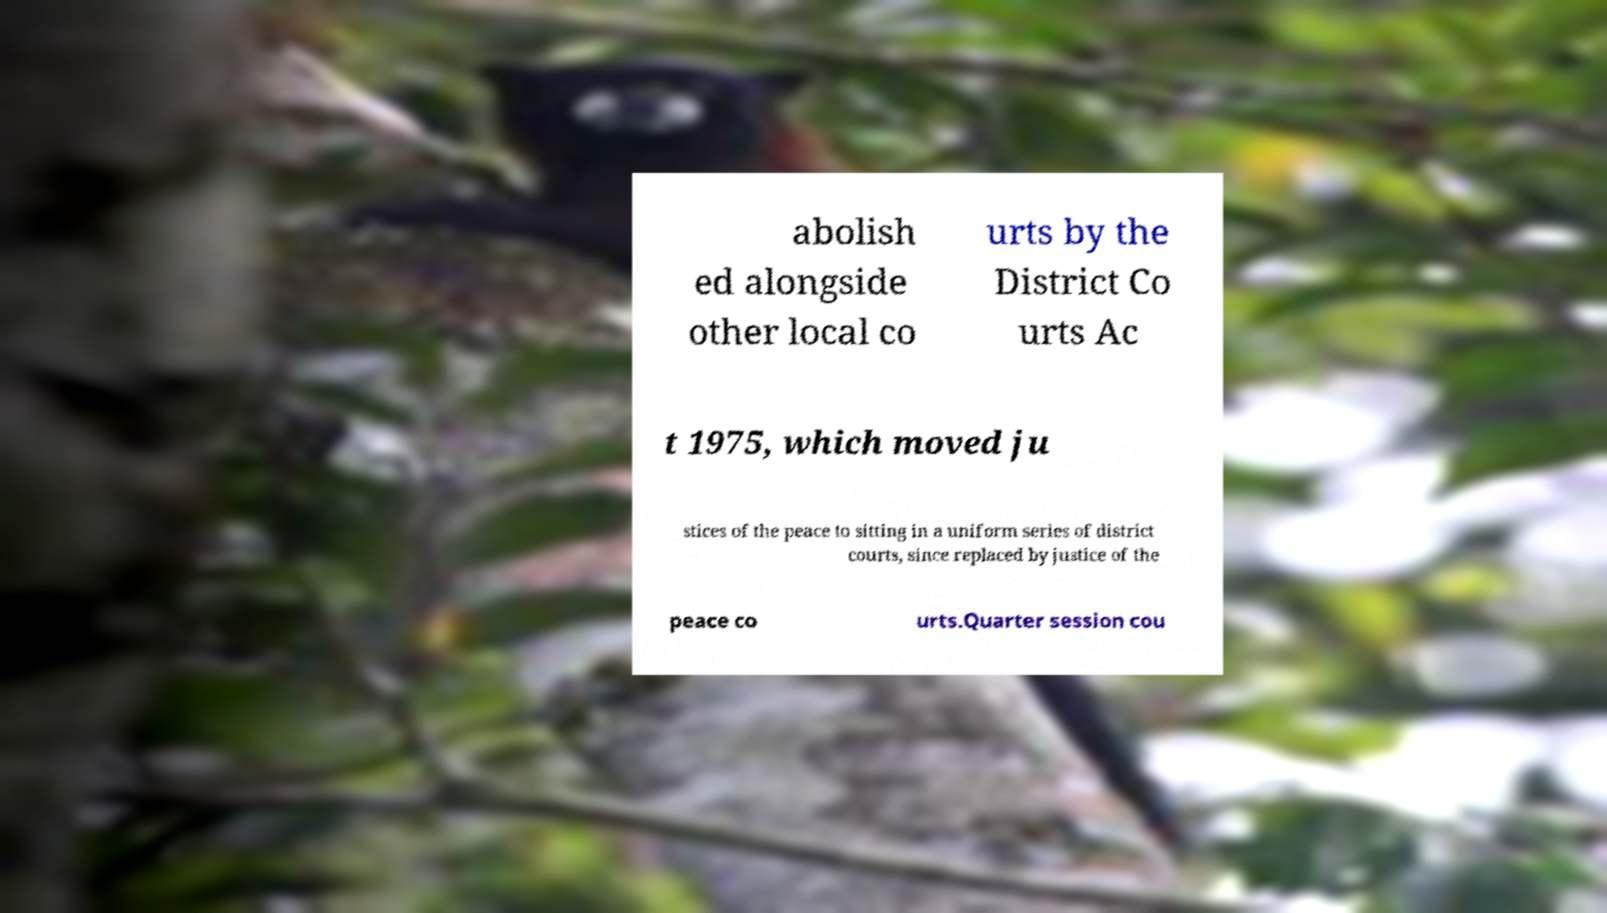Please read and relay the text visible in this image. What does it say? abolish ed alongside other local co urts by the District Co urts Ac t 1975, which moved ju stices of the peace to sitting in a uniform series of district courts, since replaced by justice of the peace co urts.Quarter session cou 